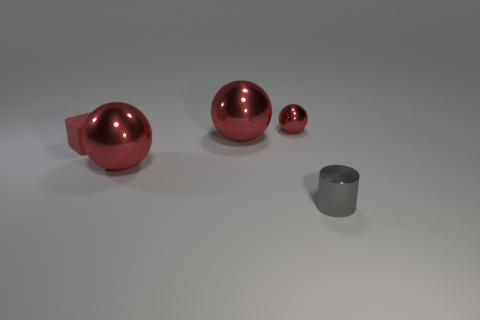How many small metal objects are to the left of the gray metallic thing and in front of the tiny shiny sphere?
Ensure brevity in your answer.  0. How many objects are either small red rubber blocks or gray cylinders that are right of the tiny red shiny ball?
Provide a short and direct response. 2. There is a thing that is on the right side of the tiny metal object that is on the left side of the gray thing; what is its shape?
Provide a short and direct response. Cylinder. How many red objects are tiny cylinders or rubber blocks?
Give a very brief answer. 1. Are there any large red spheres that are on the left side of the small metallic thing to the right of the tiny metal object that is on the left side of the tiny cylinder?
Give a very brief answer. Yes. What is the shape of the rubber thing that is the same color as the small ball?
Provide a short and direct response. Cube. Are there any other things that are the same material as the small cylinder?
Offer a terse response. Yes. How many big objects are either red metallic things or gray things?
Make the answer very short. 2. Is the shape of the large red object that is in front of the small red rubber block the same as  the small red metallic object?
Give a very brief answer. Yes. Is the number of small balls less than the number of large red rubber cylinders?
Your answer should be very brief. No. 